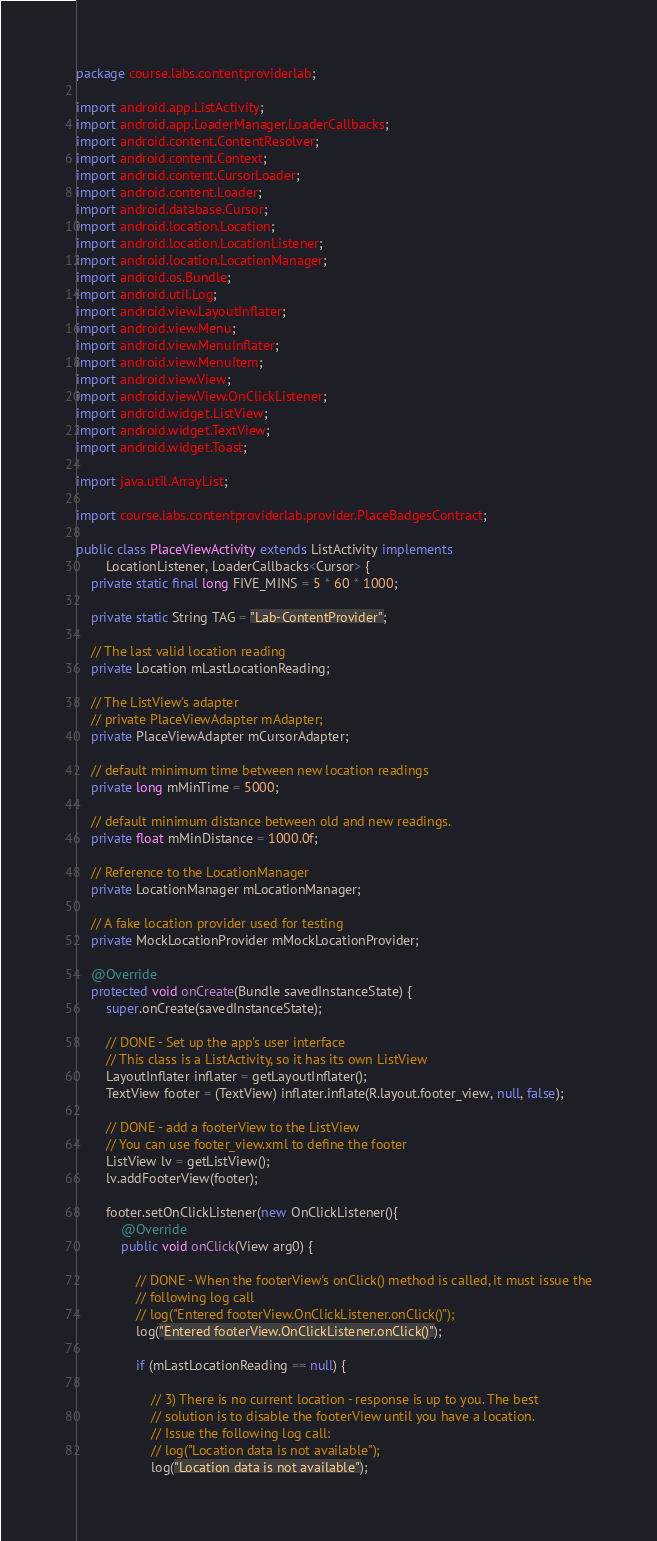<code> <loc_0><loc_0><loc_500><loc_500><_Java_>package course.labs.contentproviderlab;

import android.app.ListActivity;
import android.app.LoaderManager.LoaderCallbacks;
import android.content.ContentResolver;
import android.content.Context;
import android.content.CursorLoader;
import android.content.Loader;
import android.database.Cursor;
import android.location.Location;
import android.location.LocationListener;
import android.location.LocationManager;
import android.os.Bundle;
import android.util.Log;
import android.view.LayoutInflater;
import android.view.Menu;
import android.view.MenuInflater;
import android.view.MenuItem;
import android.view.View;
import android.view.View.OnClickListener;
import android.widget.ListView;
import android.widget.TextView;
import android.widget.Toast;

import java.util.ArrayList;

import course.labs.contentproviderlab.provider.PlaceBadgesContract;

public class PlaceViewActivity extends ListActivity implements
		LocationListener, LoaderCallbacks<Cursor> {
	private static final long FIVE_MINS = 5 * 60 * 1000;

	private static String TAG = "Lab-ContentProvider";

	// The last valid location reading
	private Location mLastLocationReading;

	// The ListView's adapter
	// private PlaceViewAdapter mAdapter;
	private PlaceViewAdapter mCursorAdapter;

	// default minimum time between new location readings
	private long mMinTime = 5000;

	// default minimum distance between old and new readings.
	private float mMinDistance = 1000.0f;

	// Reference to the LocationManager
	private LocationManager mLocationManager;

	// A fake location provider used for testing
	private MockLocationProvider mMockLocationProvider;

	@Override
	protected void onCreate(Bundle savedInstanceState) {
		super.onCreate(savedInstanceState);

        // DONE - Set up the app's user interface
        // This class is a ListActivity, so it has its own ListView
        LayoutInflater inflater = getLayoutInflater();
        TextView footer = (TextView) inflater.inflate(R.layout.footer_view, null, false);

        // DONE - add a footerView to the ListView
        // You can use footer_view.xml to define the footer
        ListView lv = getListView();
        lv.addFooterView(footer);

        footer.setOnClickListener(new OnClickListener(){
            @Override
            public void onClick(View arg0) {

                // DONE - When the footerView's onClick() method is called, it must issue the
                // following log call
                // log("Entered footerView.OnClickListener.onClick()");
                log("Entered footerView.OnClickListener.onClick()");

                if (mLastLocationReading == null) {

                    // 3) There is no current location - response is up to you. The best
                    // solution is to disable the footerView until you have a location.
                    // Issue the following log call:
                    // log("Location data is not available");
                    log("Location data is not available");</code> 